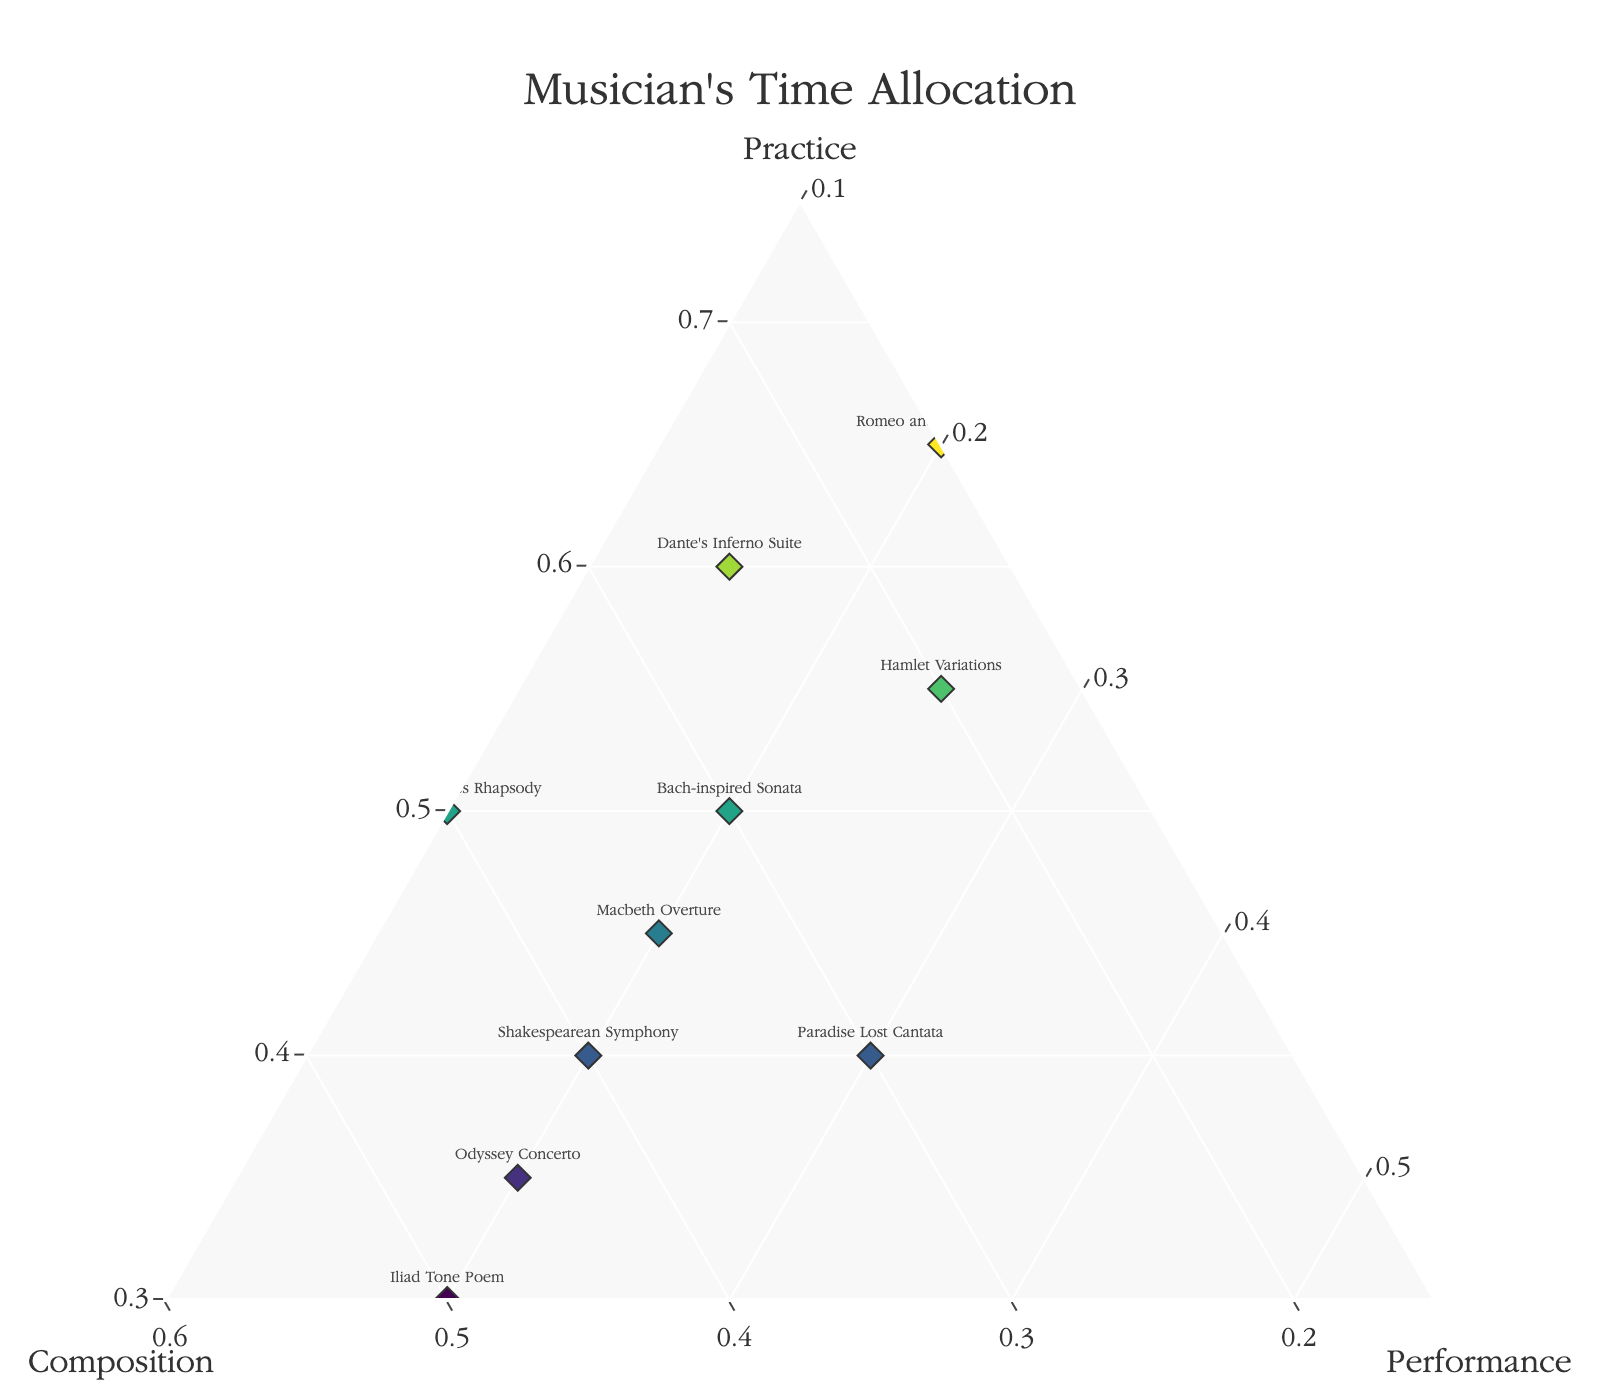What is the title of the plot? The title can usually be found at the top of the plot. In this case, the title is "Musician's Time Allocation"
Answer: Musician's Time Allocation How many data points (musicians) are represented in the plot? The number of data points corresponds to the number of unique musicians labeled on the plot. Based on the provided data, there are 10 musicians.
Answer: 10 Which musician allocates the most time to practice? To find this, we look for the data point where the 'Practice' percentage is highest. From the data, "Romeo and Juliet Etudes" has the highest practice percentage at 65%.
Answer: Romeo and Juliet Etudes Which musicians allocate equal amounts of time to performance? To answer this, we find musicians with the same 'Performance' percentage. Multiple musicians have a 20% allocation for performance: Bach-inspired Sonata, Shakespearean Symphony, Dante's Inferno Suite, Odyssey Concerto, Hamlet Variations, Macbeth Overture, and Iliad Tone Poem.
Answer: Bach-inspired Sonata, Shakespearean Symphony, Dante's Inferno Suite, Odyssey Concerto, Hamlet Variations, Macbeth Overture, Iliad Tone Poem What is the average time allocated to composition across all musicians? To calculate the average, sum up all the composition times and divide by the number of musicians: (30+40+25+45+20+35+50+15+30+40)/10 = 33
Answer: 33 Which data point is closest to the center of the plot? The center of a ternary plot is where all three categories are equal. By estimating visually, "Paradise Lost Cantata" with allocations of 40%, 30%, and 30% appears closest to this balance.
Answer: Paradise Lost Cantata Compare the time allocated to practice between "Macbeth Overture" and "Odyssey Concerto" Macbeth Overture has 45% for practice, while Odyssey Concerto has 35%. Macbeth Overture allocates a greater percentage of time to practice.
Answer: Macbeth Overture What is the sum of practice and performance time for "Dante's Inferno Suite"? Add the practice and performance times: 60 (Practice) + 15 (Performance) = 75
Answer: 75 Which musician has the least time allocated to performance? The musician with the lowest 'Performance' value is "Canterbury Tales Rhapsody" with 10%.
Answer: Canterbury Tales Rhapsody Is there any musician allocating more than 50% of their time to a single category? Checking the data for each category above 50%. "Romeo and Juliet Etudes" allocates 65% to practice, "Iliad Tone Poem" allocates 50% to composition.
Answer: Yes 